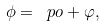Convert formula to latex. <formula><loc_0><loc_0><loc_500><loc_500>\phi = \ p o + \varphi ,</formula> 